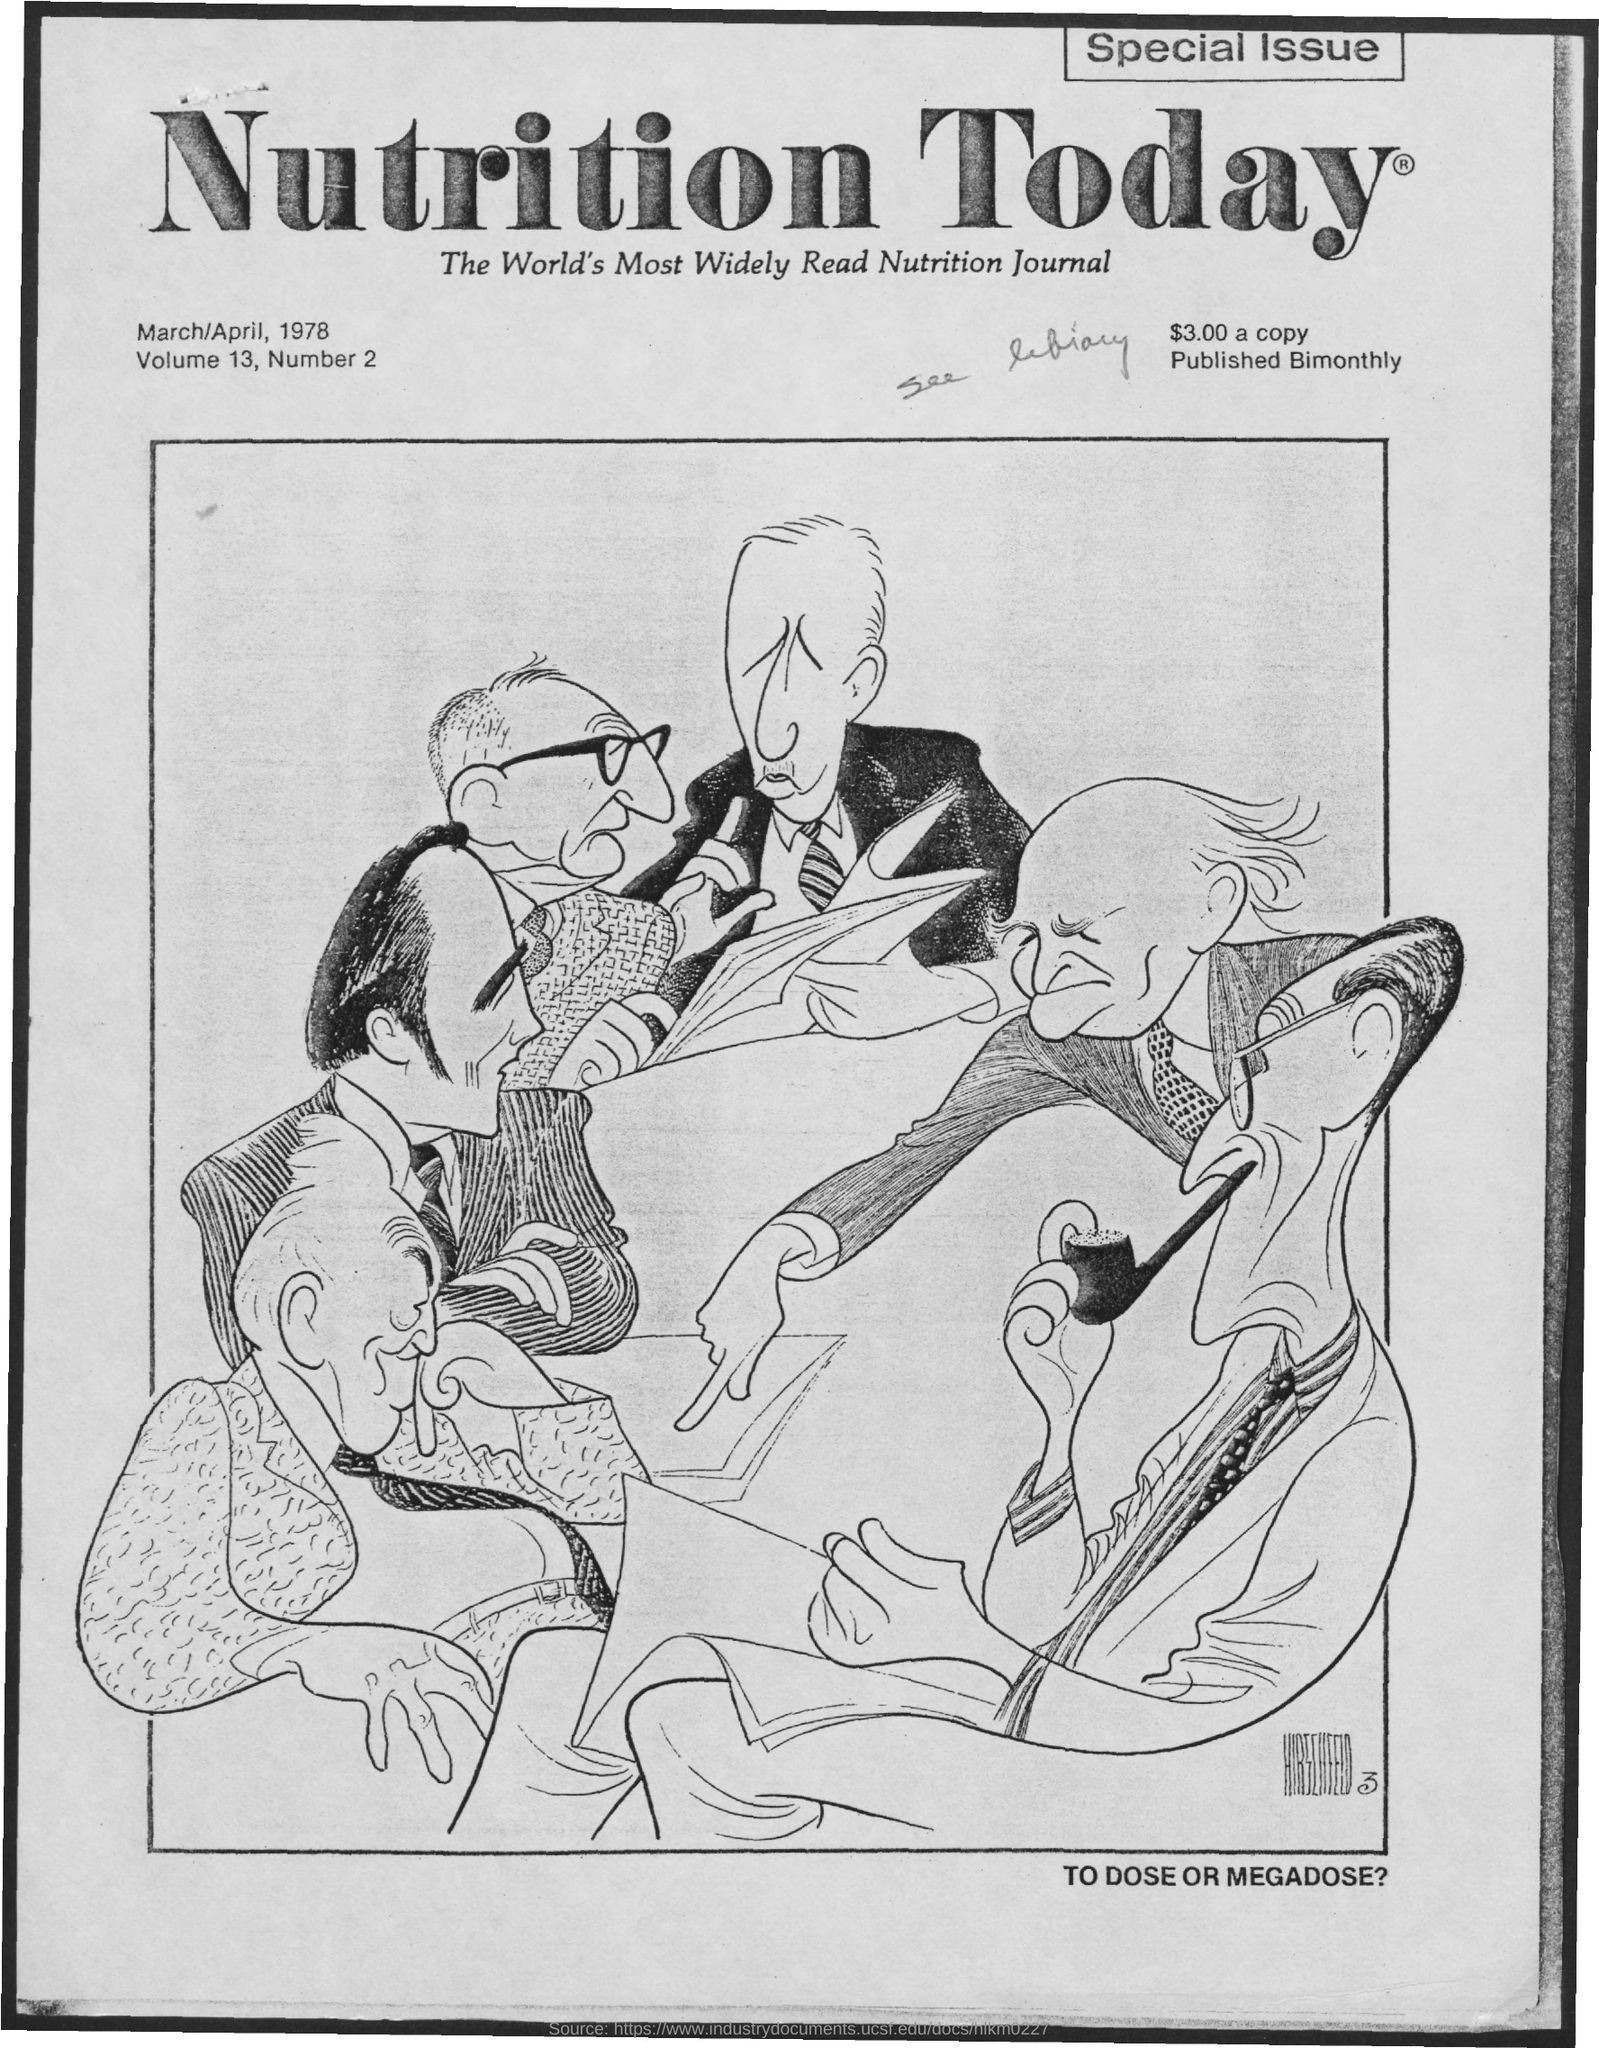Outline some significant characteristics in this image. Bimonthly is the frequency of its publication. The title of the document is 'Nutrition Today.' The volume is 13. 